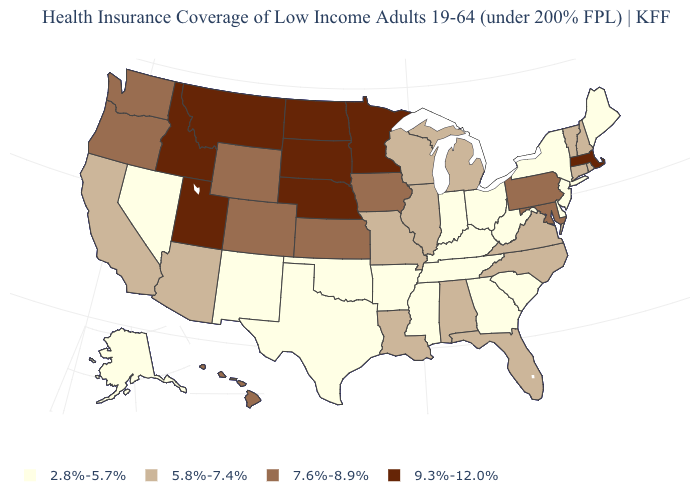What is the lowest value in states that border North Carolina?
Be succinct. 2.8%-5.7%. Name the states that have a value in the range 7.6%-8.9%?
Write a very short answer. Colorado, Hawaii, Iowa, Kansas, Maryland, Oregon, Pennsylvania, Washington, Wyoming. Does West Virginia have a lower value than Idaho?
Concise answer only. Yes. Which states hav the highest value in the West?
Concise answer only. Idaho, Montana, Utah. Does Alaska have the highest value in the USA?
Write a very short answer. No. What is the lowest value in the USA?
Be succinct. 2.8%-5.7%. What is the value of Maryland?
Give a very brief answer. 7.6%-8.9%. Among the states that border Florida , which have the highest value?
Write a very short answer. Alabama. What is the value of Utah?
Short answer required. 9.3%-12.0%. Does Florida have the lowest value in the South?
Concise answer only. No. Among the states that border Florida , which have the lowest value?
Short answer required. Georgia. Which states hav the highest value in the South?
Be succinct. Maryland. Is the legend a continuous bar?
Give a very brief answer. No. What is the value of Georgia?
Answer briefly. 2.8%-5.7%. 